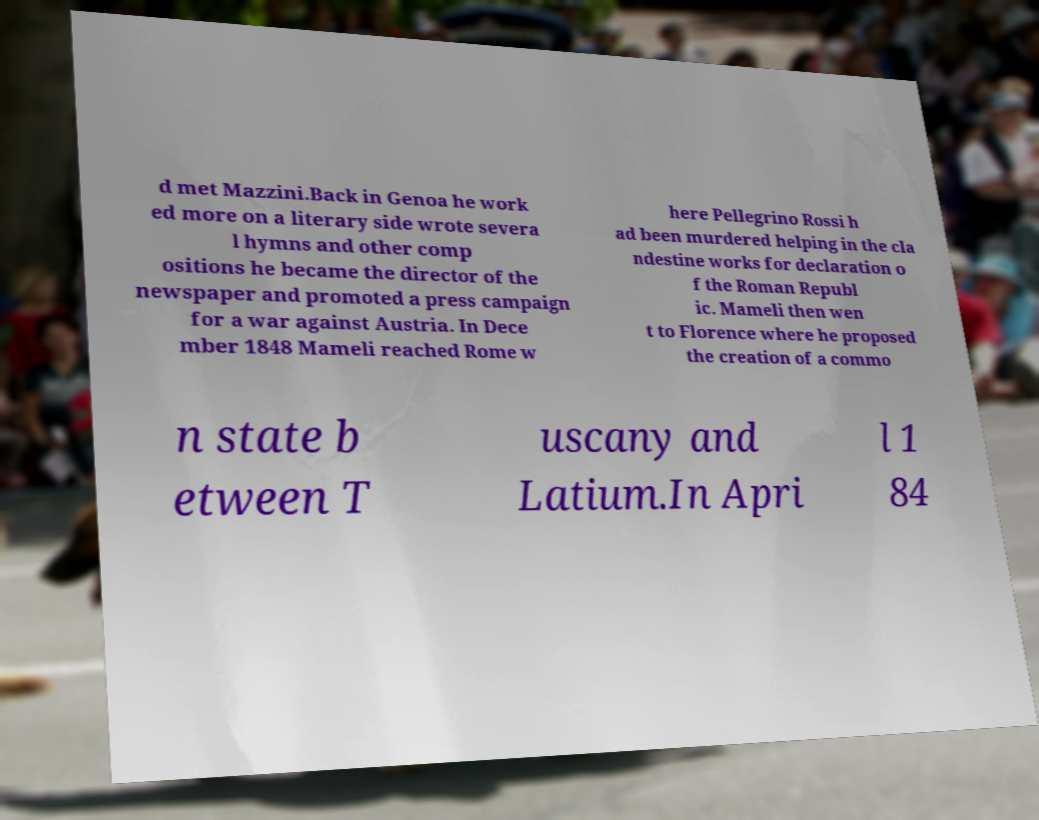There's text embedded in this image that I need extracted. Can you transcribe it verbatim? d met Mazzini.Back in Genoa he work ed more on a literary side wrote severa l hymns and other comp ositions he became the director of the newspaper and promoted a press campaign for a war against Austria. In Dece mber 1848 Mameli reached Rome w here Pellegrino Rossi h ad been murdered helping in the cla ndestine works for declaration o f the Roman Republ ic. Mameli then wen t to Florence where he proposed the creation of a commo n state b etween T uscany and Latium.In Apri l 1 84 